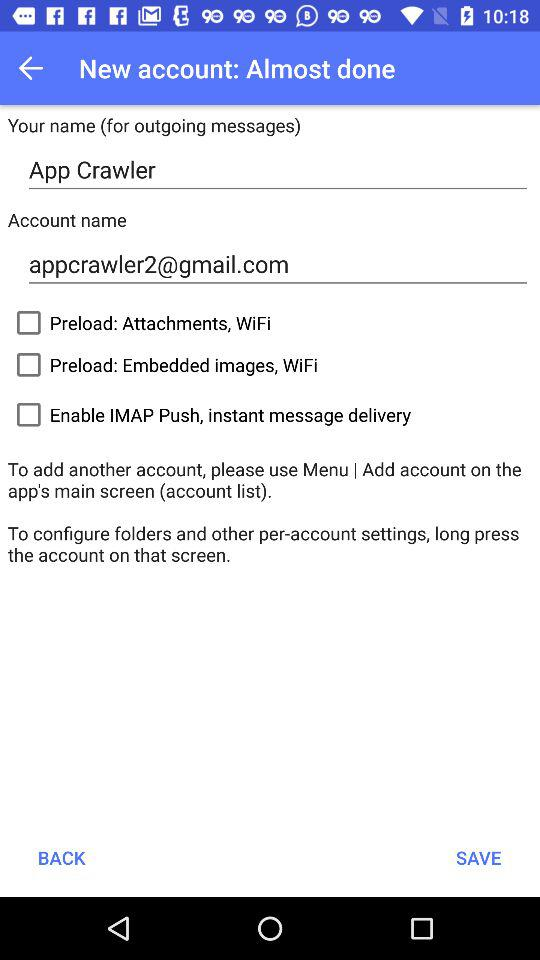What is the user name? The user name is App Crawler. 